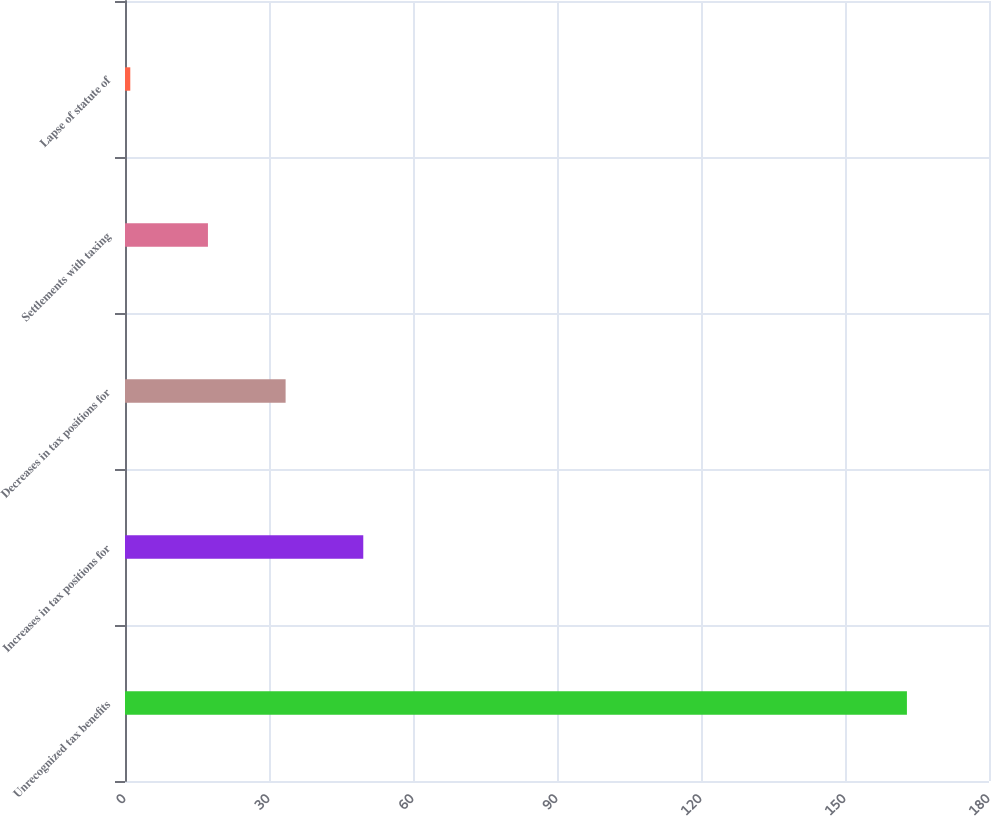<chart> <loc_0><loc_0><loc_500><loc_500><bar_chart><fcel>Unrecognized tax benefits<fcel>Increases in tax positions for<fcel>Decreases in tax positions for<fcel>Settlements with taxing<fcel>Lapse of statute of<nl><fcel>162.9<fcel>49.64<fcel>33.46<fcel>17.28<fcel>1.1<nl></chart> 